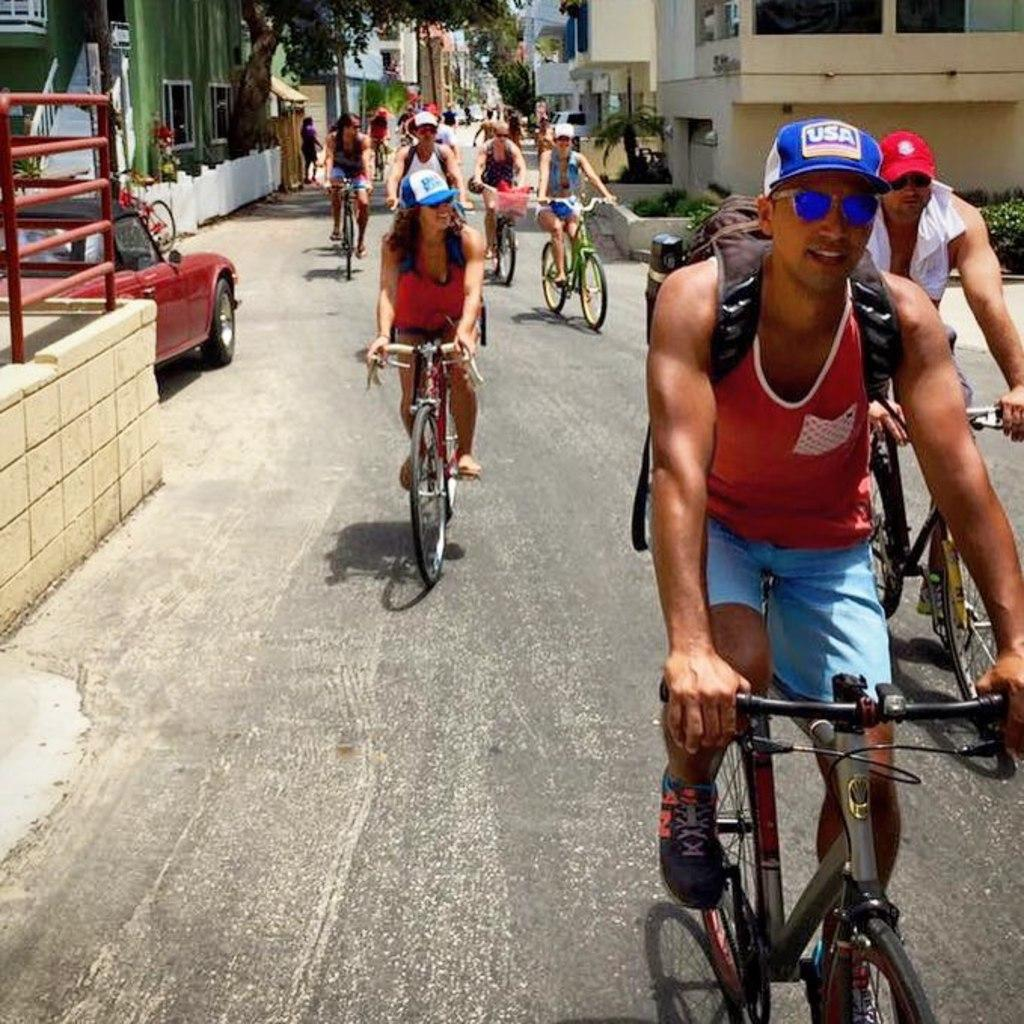What are the people in the image doing? The people in the image are riding bicycles. Where are the people riding their bicycles? The people are on a road. What can be seen in the background of the image? There are buildings visible in the background. Is there any other mode of transportation present in the image? Yes, there is a car parked on the road in the image. What type of spring can be seen in the image? There is no spring present in the image. How does the tramp contribute to the scene in the image? There is no tramp present in the image. 